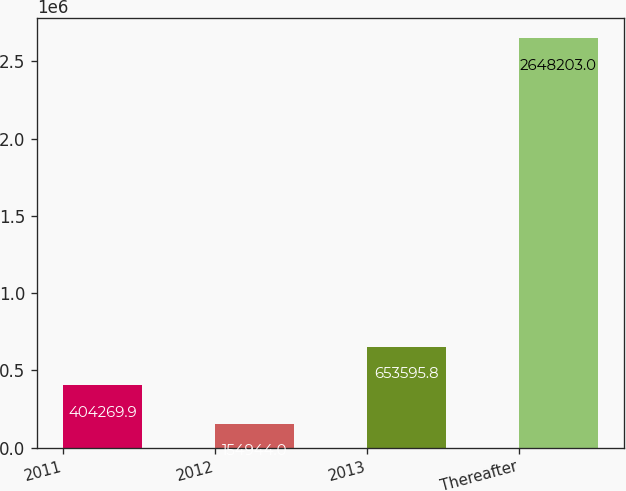Convert chart to OTSL. <chart><loc_0><loc_0><loc_500><loc_500><bar_chart><fcel>2011<fcel>2012<fcel>2013<fcel>Thereafter<nl><fcel>404270<fcel>154944<fcel>653596<fcel>2.6482e+06<nl></chart> 